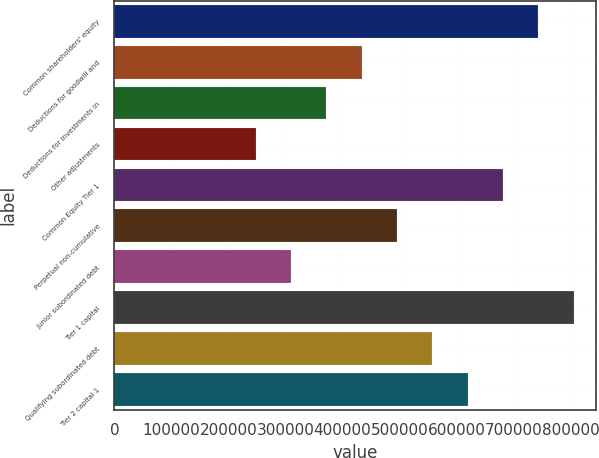Convert chart. <chart><loc_0><loc_0><loc_500><loc_500><bar_chart><fcel>Common shareholders' equity<fcel>Deductions for goodwill and<fcel>Deductions for investments in<fcel>Other adjustments<fcel>Common Equity Tier 1<fcel>Perpetual non-cumulative<fcel>Junior subordinated debt<fcel>Tier 1 capital<fcel>Qualifying subordinated debt<fcel>Tier 2 capital 1<nl><fcel>743057<fcel>433454<fcel>371533<fcel>247692<fcel>681137<fcel>495375<fcel>309612<fcel>804978<fcel>557295<fcel>619216<nl></chart> 